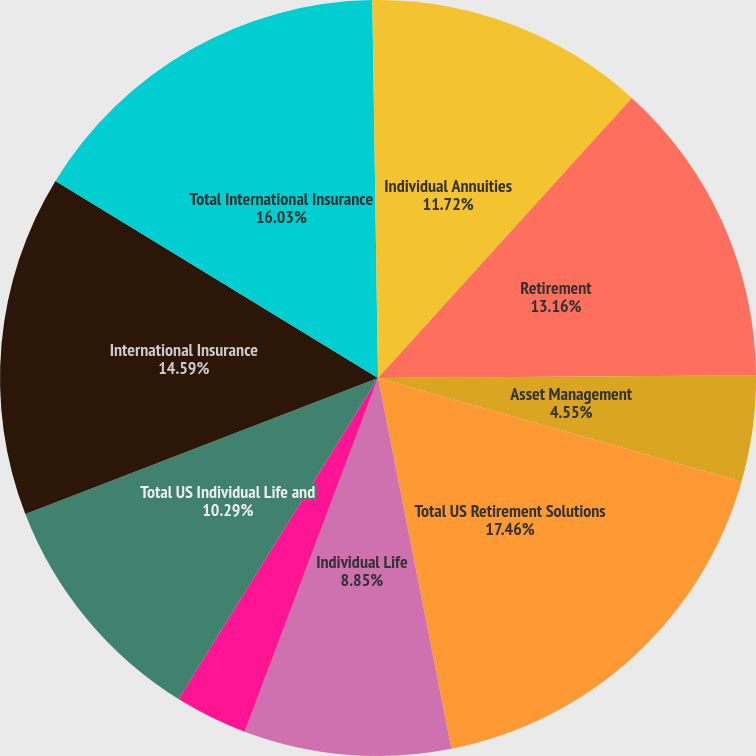<chart> <loc_0><loc_0><loc_500><loc_500><pie_chart><fcel>Individual Annuities<fcel>Retirement<fcel>Asset Management<fcel>Total US Retirement Solutions<fcel>Individual Life<fcel>Group Insurance<fcel>Total US Individual Life and<fcel>International Insurance<fcel>Total International Insurance<fcel>Corporate and Other operations<nl><fcel>11.72%<fcel>13.16%<fcel>4.55%<fcel>17.46%<fcel>8.85%<fcel>3.11%<fcel>10.29%<fcel>14.59%<fcel>16.03%<fcel>0.24%<nl></chart> 